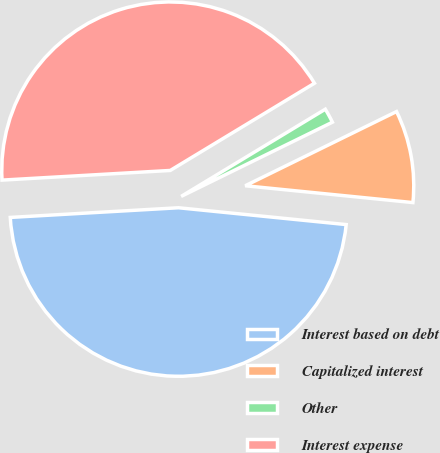Convert chart. <chart><loc_0><loc_0><loc_500><loc_500><pie_chart><fcel>Interest based on debt<fcel>Capitalized interest<fcel>Other<fcel>Interest expense<nl><fcel>47.5%<fcel>8.85%<fcel>1.4%<fcel>42.26%<nl></chart> 